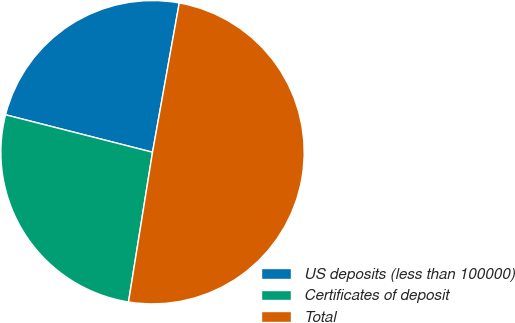Convert chart to OTSL. <chart><loc_0><loc_0><loc_500><loc_500><pie_chart><fcel>US deposits (less than 100000)<fcel>Certificates of deposit<fcel>Total<nl><fcel>23.85%<fcel>26.44%<fcel>49.71%<nl></chart> 